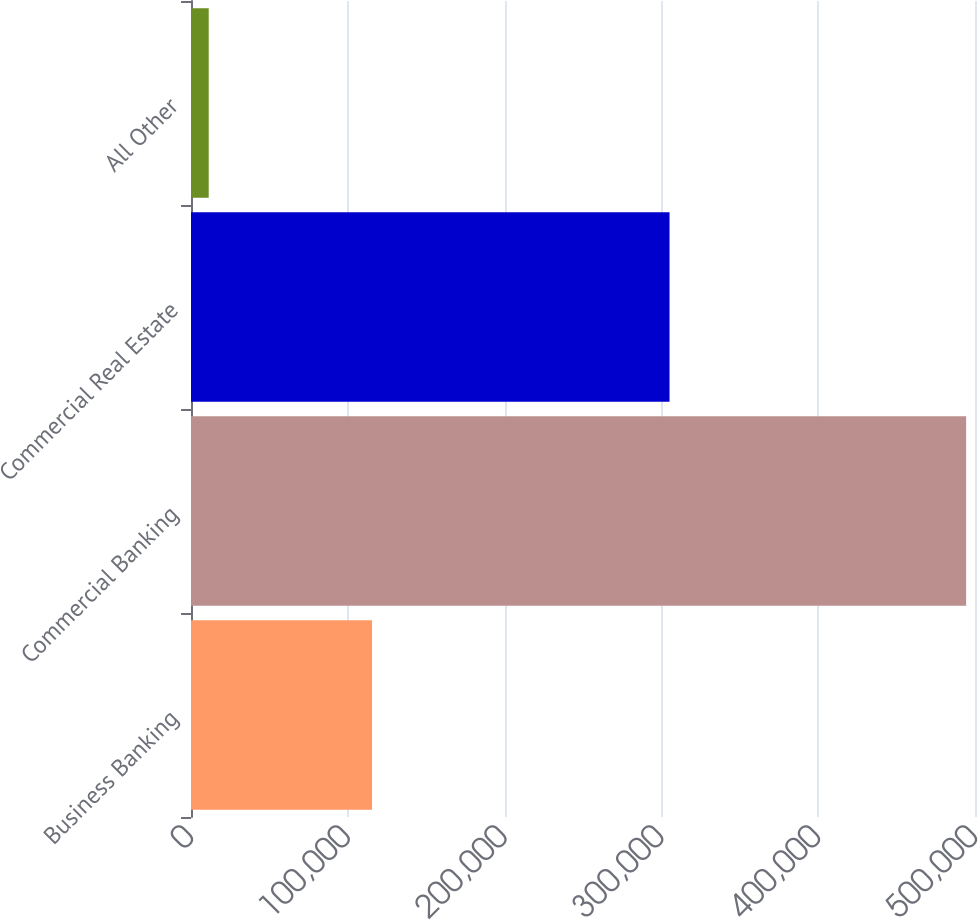Convert chart to OTSL. <chart><loc_0><loc_0><loc_500><loc_500><bar_chart><fcel>Business Banking<fcel>Commercial Banking<fcel>Commercial Real Estate<fcel>All Other<nl><fcel>115459<fcel>494349<fcel>305192<fcel>11300<nl></chart> 